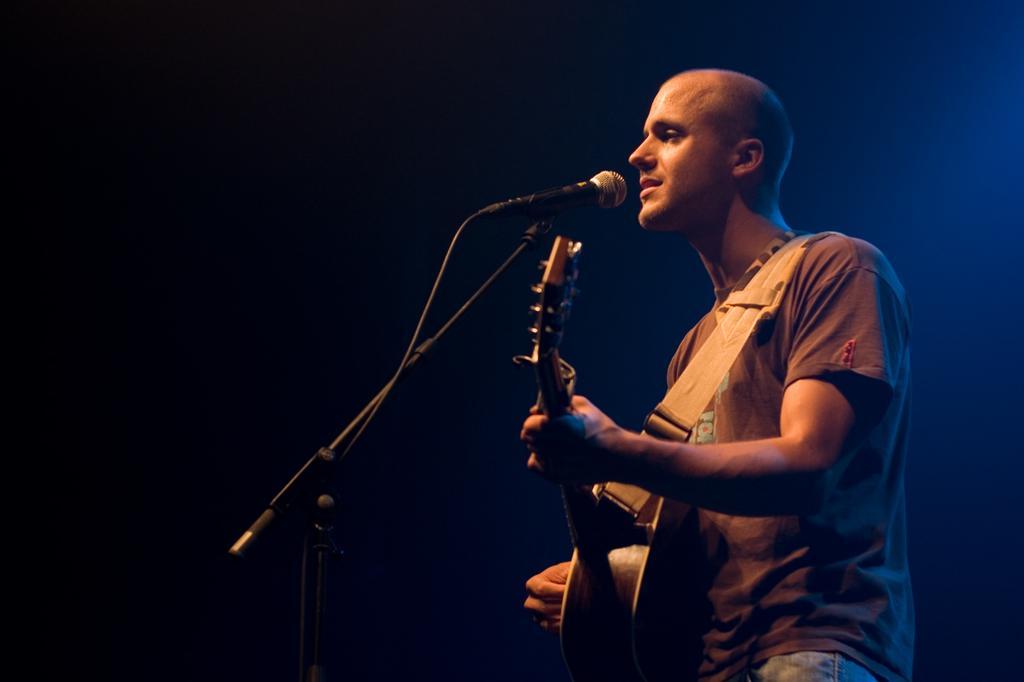Could you give a brief overview of what you see in this image? As we can see in the image there is a man holding guitar and singing on mic. 